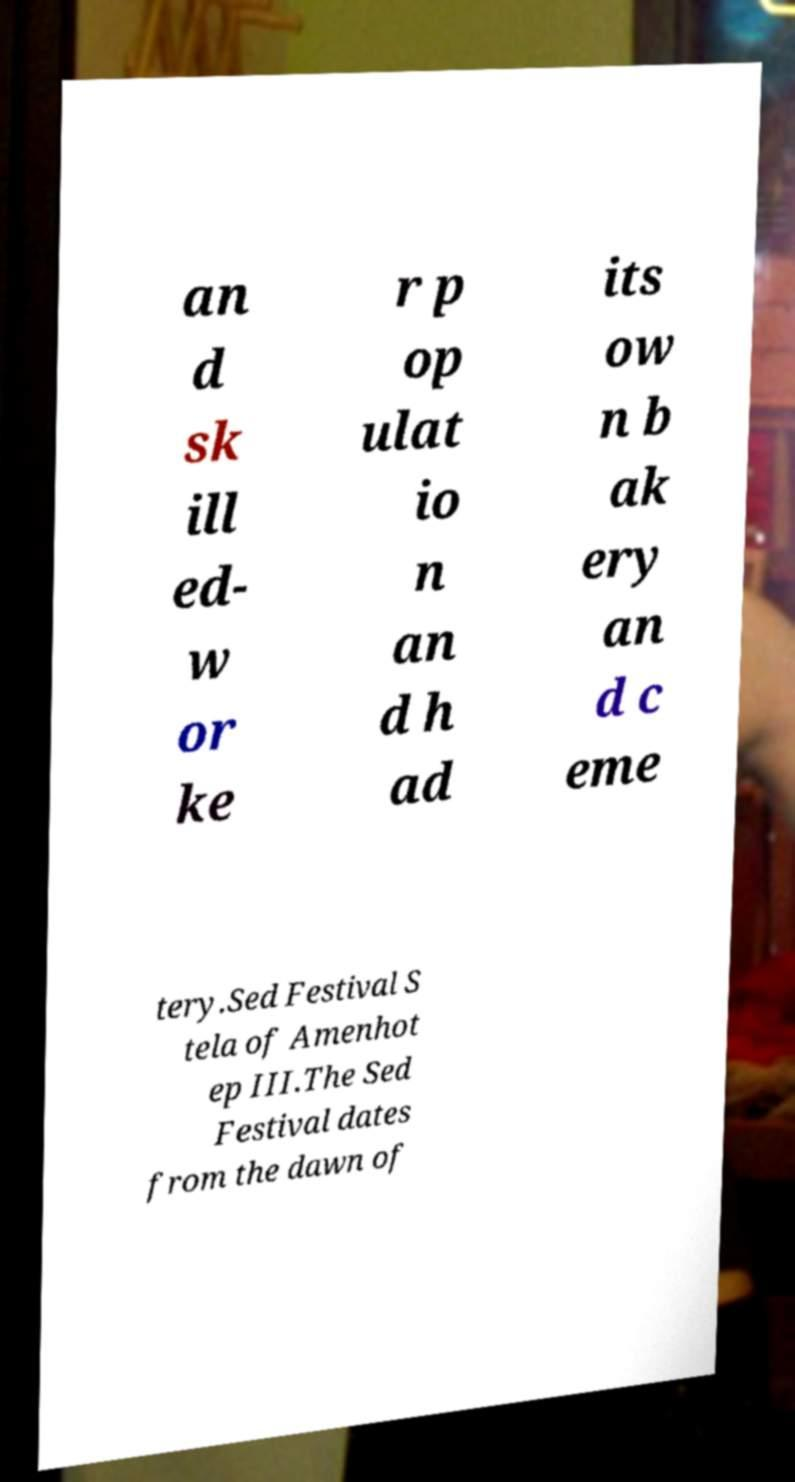For documentation purposes, I need the text within this image transcribed. Could you provide that? an d sk ill ed- w or ke r p op ulat io n an d h ad its ow n b ak ery an d c eme tery.Sed Festival S tela of Amenhot ep III.The Sed Festival dates from the dawn of 